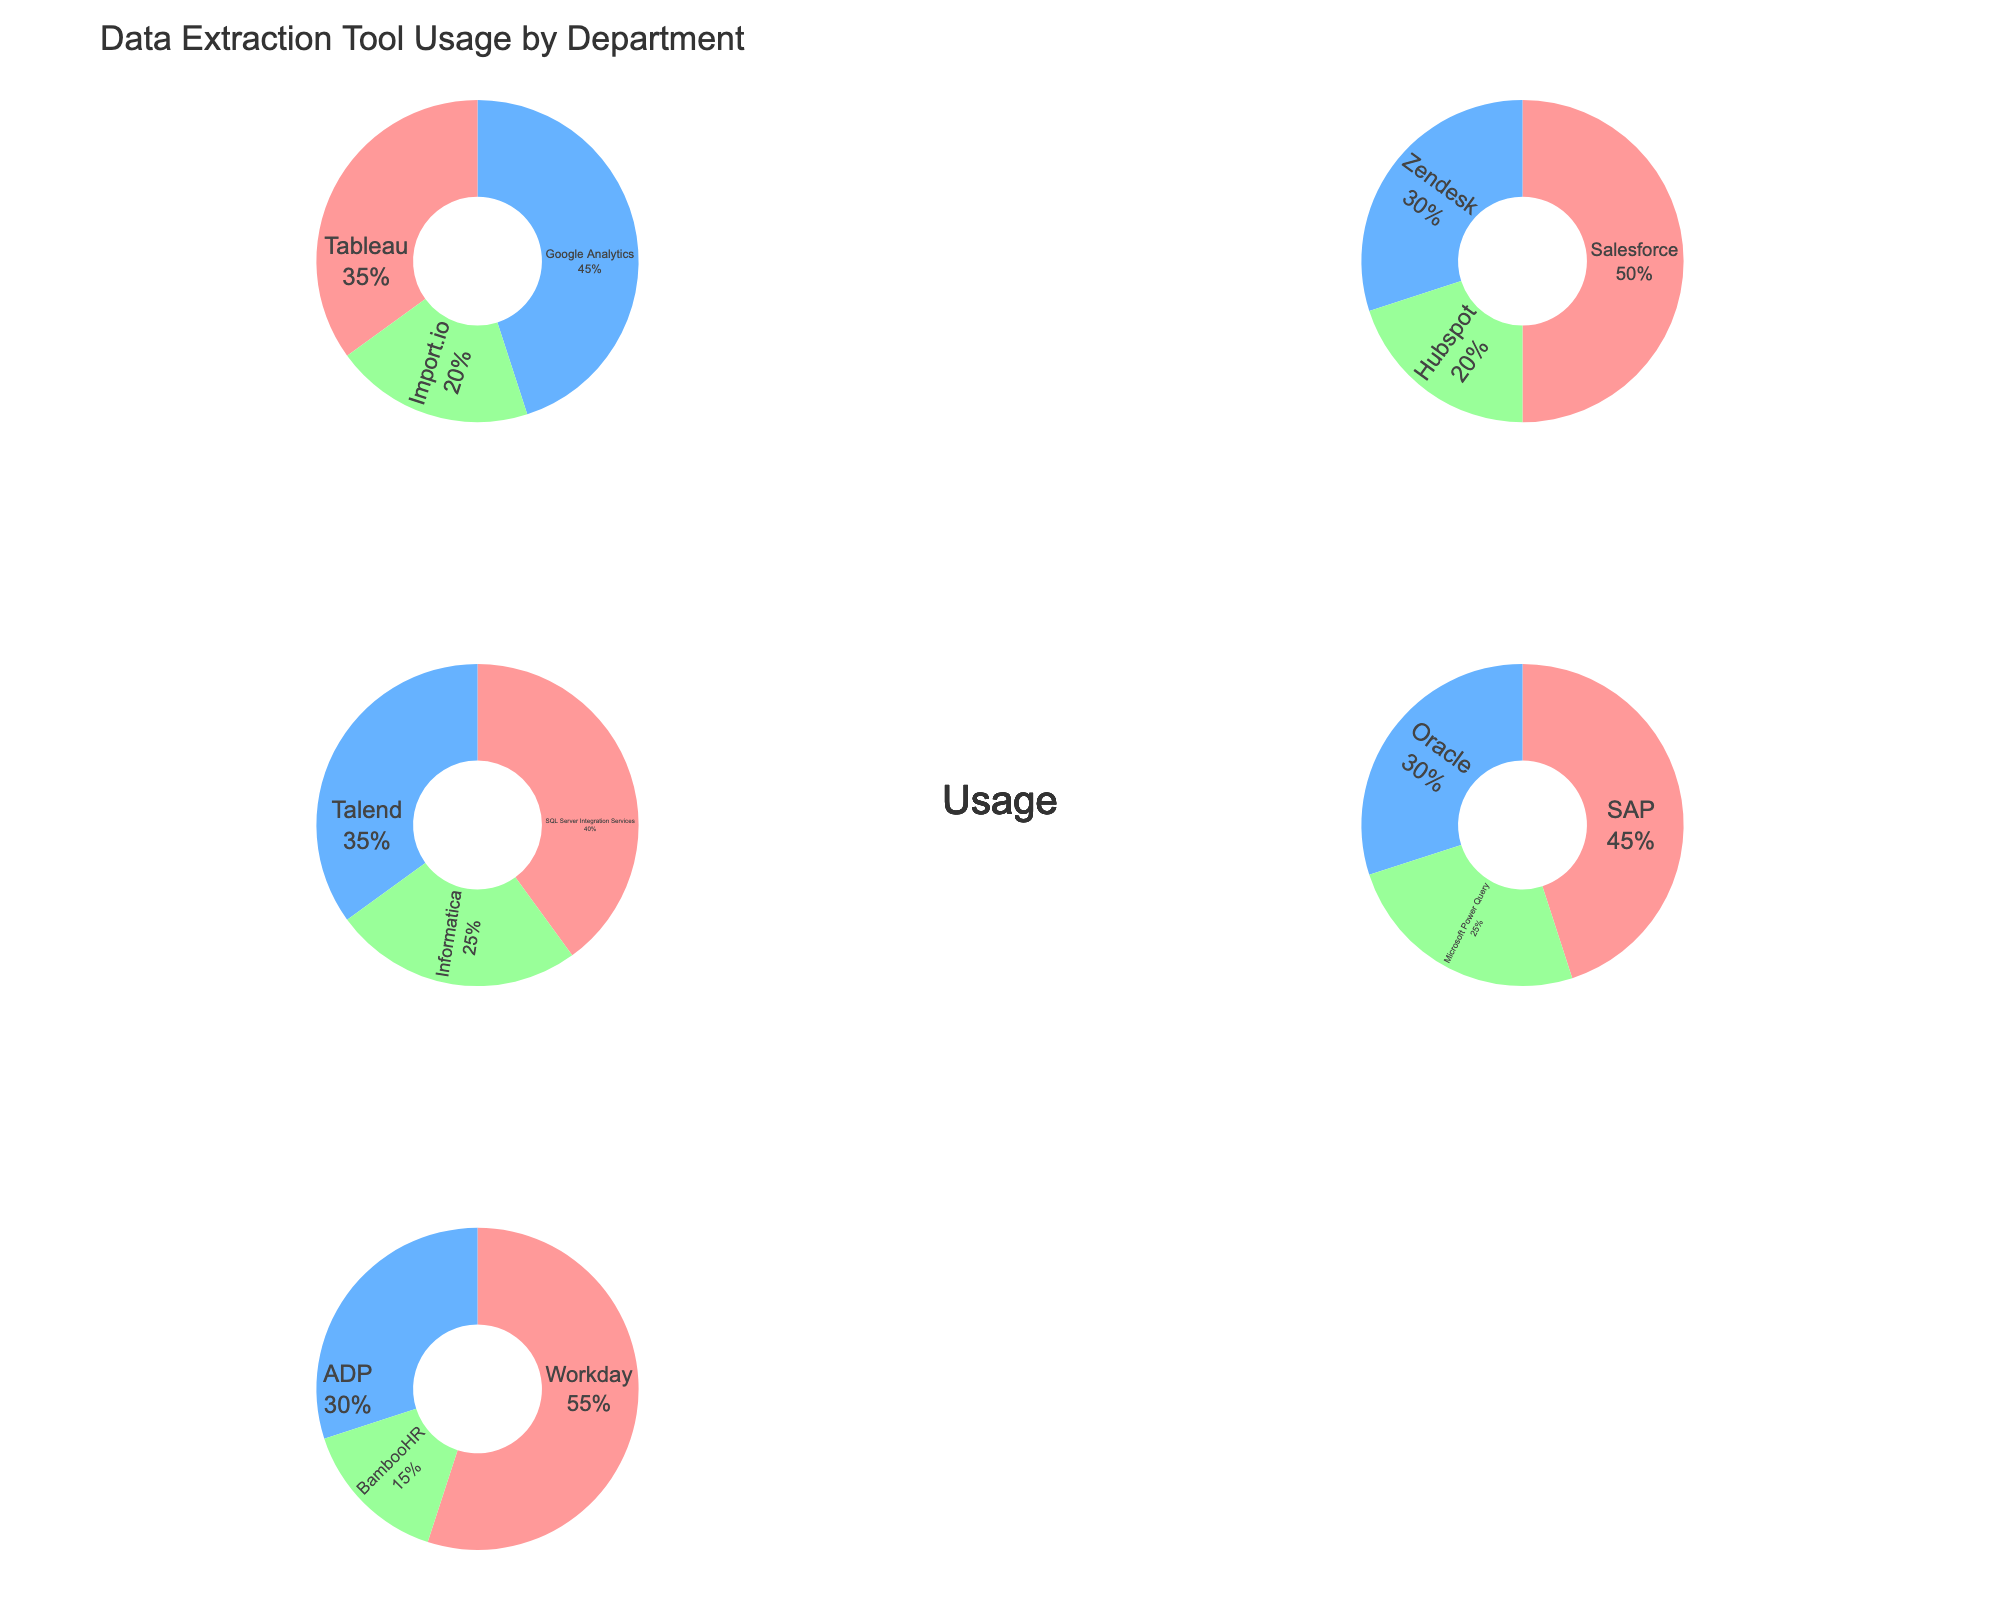What is the data extraction tool with the highest usage in the Marketing department? The pie chart for the Marketing department shows the largest segment belongs to Google Analytics.
Answer: Google Analytics How many data extraction tools are used by the Sales department? The Sales department's pie chart shows three different segments corresponding to Salesforce, Zendesk, and Hubspot.
Answer: 3 What percentage of usage does Workday represent in the HR department? In the HR department's pie chart, the segment for Workday is labeled with 55%.
Answer: 55% Which department uses Tableau the most? By examining the pie charts, Tableau only appears in the Marketing department, with 35% usage.
Answer: Marketing Compare the usage of SQL Server Integration Services in the IT department to the usage of Salesforce in the Sales department. Which one is higher and by how much? SQL Server Integration Services has 40% usage in IT, and Salesforce has 50% usage in Sales. Since 50% - 40% = 10%, Salesforce's usage is higher by 10%.
Answer: Salesforce by 10% What's the combined usage percentage of ADP and BambooHR in the HR department? In the HR department, ADP is 30% and BambooHR is 15%. The combined percentage is 30% + 15% = 45%.
Answer: 45% Among the departments shown, which one has the highest single tool usage and what tool is it? The pie charts show that HR's Workday segment has the highest percentage at 55%.
Answer: HR, Workday What tool has the lowest usage across all departments, and what is its usage percentage? BambooHR in the HR department has the lowest percentage label of 15%.
Answer: BambooHR, 15% Compare the usage percentages of Tableau in Marketing and Talend in IT. Which is more, and by what percentage? Tableau in Marketing has 35%, and Talend in IT has 35%, so they are equal.
Answer: They are equal 